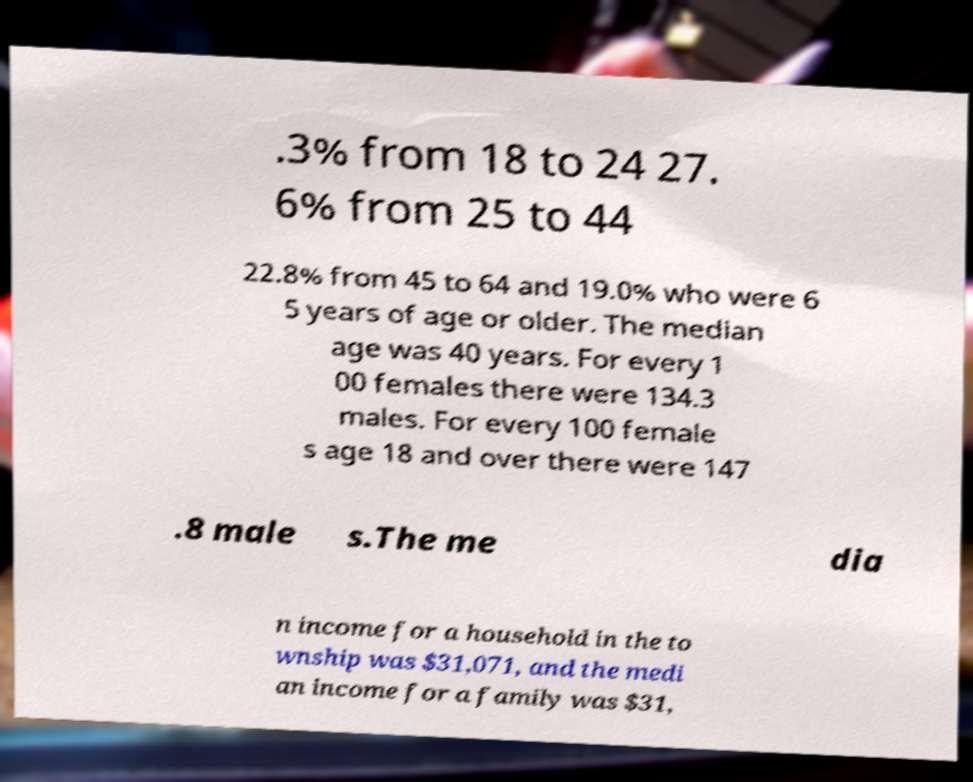I need the written content from this picture converted into text. Can you do that? .3% from 18 to 24 27. 6% from 25 to 44 22.8% from 45 to 64 and 19.0% who were 6 5 years of age or older. The median age was 40 years. For every 1 00 females there were 134.3 males. For every 100 female s age 18 and over there were 147 .8 male s.The me dia n income for a household in the to wnship was $31,071, and the medi an income for a family was $31, 